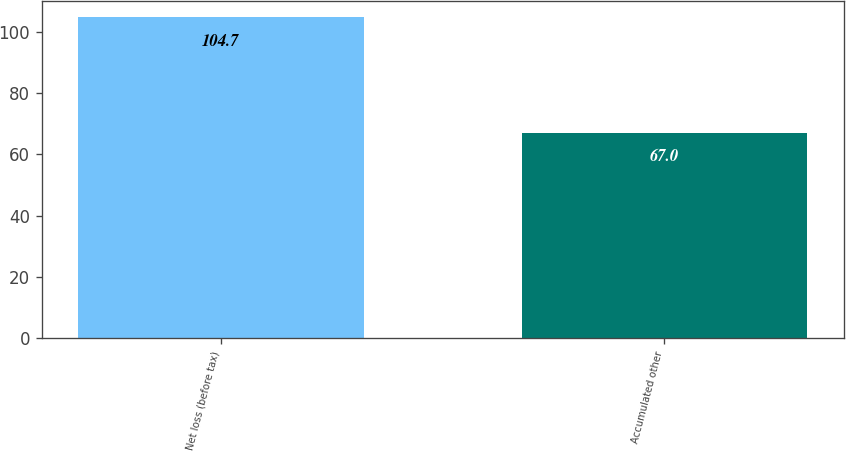Convert chart to OTSL. <chart><loc_0><loc_0><loc_500><loc_500><bar_chart><fcel>Net loss (before tax)<fcel>Accumulated other<nl><fcel>104.7<fcel>67<nl></chart> 